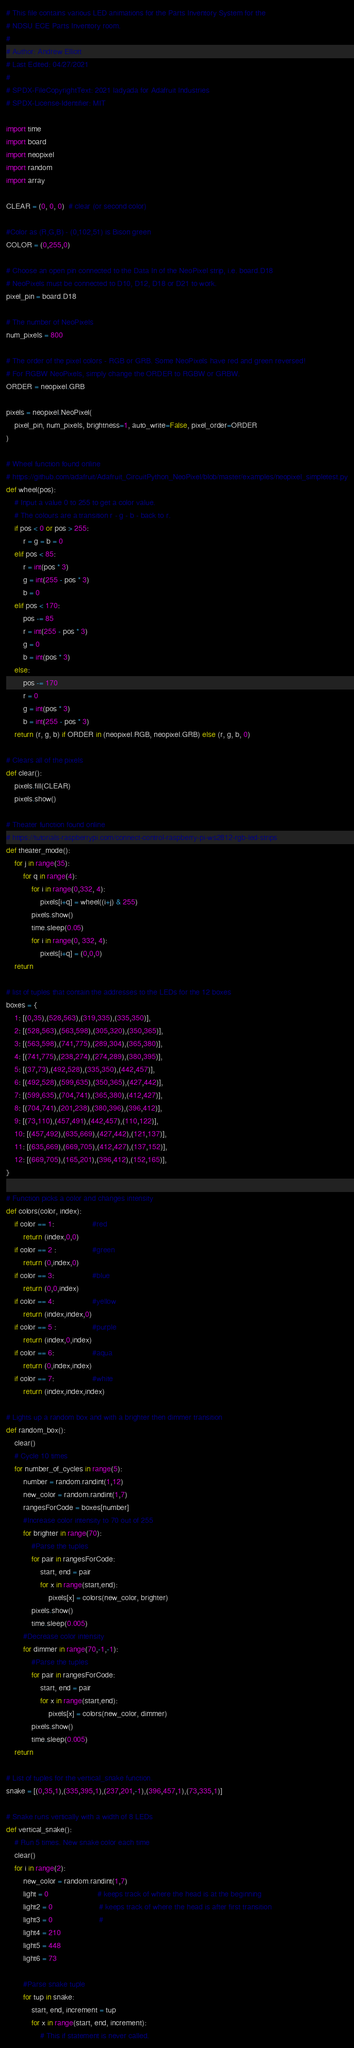<code> <loc_0><loc_0><loc_500><loc_500><_Python_># This file contains various LED animations for the Parts Inventory System for the 
# NDSU ECE Parts Inventory room.
#
# Author: Andrew Elliott
# Last Edited: 04/27/2021
#
# SPDX-FileCopyrightText: 2021 ladyada for Adafruit Industries
# SPDX-License-Identifier: MIT

import time
import board
import neopixel
import random
import array
 
CLEAR = (0, 0, 0)  # clear (or second color)

#Color as (R,G,B) - (0,102,51) is Bison green
COLOR = (0,255,0)

# Choose an open pin connected to the Data In of the NeoPixel strip, i.e. board.D18
# NeoPixels must be connected to D10, D12, D18 or D21 to work.
pixel_pin = board.D18
 
# The number of NeoPixels
num_pixels = 800
 
# The order of the pixel colors - RGB or GRB. Some NeoPixels have red and green reversed!
# For RGBW NeoPixels, simply change the ORDER to RGBW or GRBW.
ORDER = neopixel.GRB
 
pixels = neopixel.NeoPixel(
    pixel_pin, num_pixels, brightness=1, auto_write=False, pixel_order=ORDER
)

# Wheel function found online 
# https://github.com/adafruit/Adafruit_CircuitPython_NeoPixel/blob/master/examples/neopixel_simpletest.py
def wheel(pos):
    # Input a value 0 to 255 to get a color value.
    # The colours are a transition r - g - b - back to r.
    if pos < 0 or pos > 255:
        r = g = b = 0
    elif pos < 85:
        r = int(pos * 3)
        g = int(255 - pos * 3)
        b = 0
    elif pos < 170:
        pos -= 85
        r = int(255 - pos * 3)
        g = 0
        b = int(pos * 3)
    else:
        pos -= 170
        r = 0
        g = int(pos * 3)
        b = int(255 - pos * 3)
    return (r, g, b) if ORDER in (neopixel.RGB, neopixel.GRB) else (r, g, b, 0)

# Clears all of the pixels
def clear():
    pixels.fill(CLEAR)
    pixels.show()

# Theater function found online
# https://tutorials-raspberrypi.com/connect-control-raspberry-pi-ws2812-rgb-led-strips
def theater_mode():
    for j in range(35):
        for q in range(4):
            for i in range(0,332, 4):
                pixels[i+q] = wheel((i+j) & 255)
            pixels.show()
            time.sleep(0.05)
            for i in range(0, 332, 4):
                pixels[i+q] = (0,0,0)
    return

# list of tuples that contain the addresses to the LEDs for the 12 boxes
boxes = {
    1: [(0,35),(528,563),(319,335),(335,350)],
    2: [(528,563),(563,598),(305,320),(350,365)],
    3: [(563,598),(741,775),(289,304),(365,380)],
    4: [(741,775),(238,274),(274,289),(380,395)],
    5: [(37,73),(492,528),(335,350),(442,457)],
    6: [(492,528),(599,635),(350,365),(427,442)],
    7: [(599,635),(704,741),(365,380),(412,427)],
    8: [(704,741),(201,238),(380,396),(396,412)],
    9: [(73,110),(457,491),(442,457),(110,122)],
    10: [(457,492),(635,669),(427,442),(121,137)],
    11: [(635,669),(669,705),(412,427),(137,152)],
    12: [(669,705),(165,201),(396,412),(152,165)],
}

# Function picks a color and changes intensity
def colors(color, index):
    if color == 1:                  #red
        return (index,0,0)
    if color == 2 :                 #green   
        return (0,index,0)
    if color == 3:                  #blue
        return (0,0,index)
    if color == 4:                  #yellow
        return (index,index,0)
    if color == 5 :                 #purple   
        return (index,0,index)
    if color == 6:                  #aqua
        return (0,index,index)
    if color == 7:                  #white
        return (index,index,index)

# Lights up a random box and with a brighter then dimmer transition
def random_box():
    clear()
    # Cycle 10 times
    for number_of_cycles in range(5):
        number = random.randint(1,12)
        new_color = random.randint(1,7)
        rangesForCode = boxes[number]
        #Increase color intensity to 70 out of 255
        for brighter in range(70):
            #Parse the tuples
            for pair in rangesForCode:
                start, end = pair
                for x in range(start,end):
                    pixels[x] = colors(new_color, brighter)       
            pixels.show()
            time.sleep(0.005)
        #Decrease color intensity
        for dimmer in range(70,-1,-1):
            #Parse the tuples
            for pair in rangesForCode:
                start, end = pair
                for x in range(start,end):
                    pixels[x] = colors(new_color, dimmer)
            pixels.show()
            time.sleep(0.005)
    return

# List of tuples for the vertical_snake function.
snake = [(0,35,1),(335,395,1),(237,201,-1),(396,457,1),(73,335,1)]

# Snake runs vertically with a width of 8 LEDs
def vertical_snake():
    # Run 5 times. New snake color each time
    clear()
    for i in range(2):
        new_color = random.randint(1,7)
        light = 0                       # keeps track of where the head is at the beginning
        light2 = 0                      # keeps track of where the head is after first transition
        light3 = 0                      # 
        light4 = 210
        light5 = 448
        light6 = 73

        #Parse snake tuple
        for tup in snake:
            start, end, increment = tup
            for x in range(start, end, increment):
                # This if statement is never called. </code> 